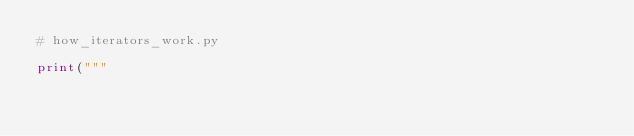Convert code to text. <code><loc_0><loc_0><loc_500><loc_500><_Python_># how_iterators_work.py

print("""</code> 